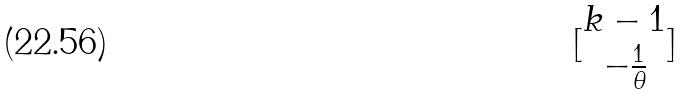Convert formula to latex. <formula><loc_0><loc_0><loc_500><loc_500>[ \begin{matrix} k - 1 \\ - \frac { 1 } { \theta } \end{matrix} ]</formula> 